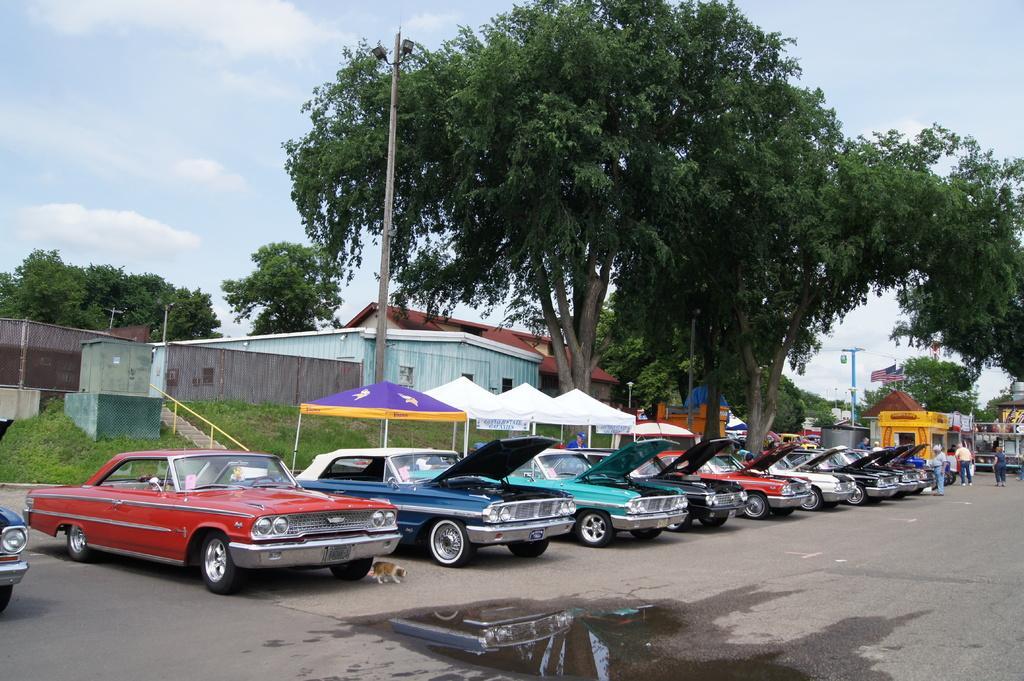Please provide a concise description of this image. In this image, we can see so many vehicles are parked on the road. Background we can see stalls, houses, stairs, rods, poles, trees, street lights. On the right side of the image, we can see few people. Background there is a sky. 